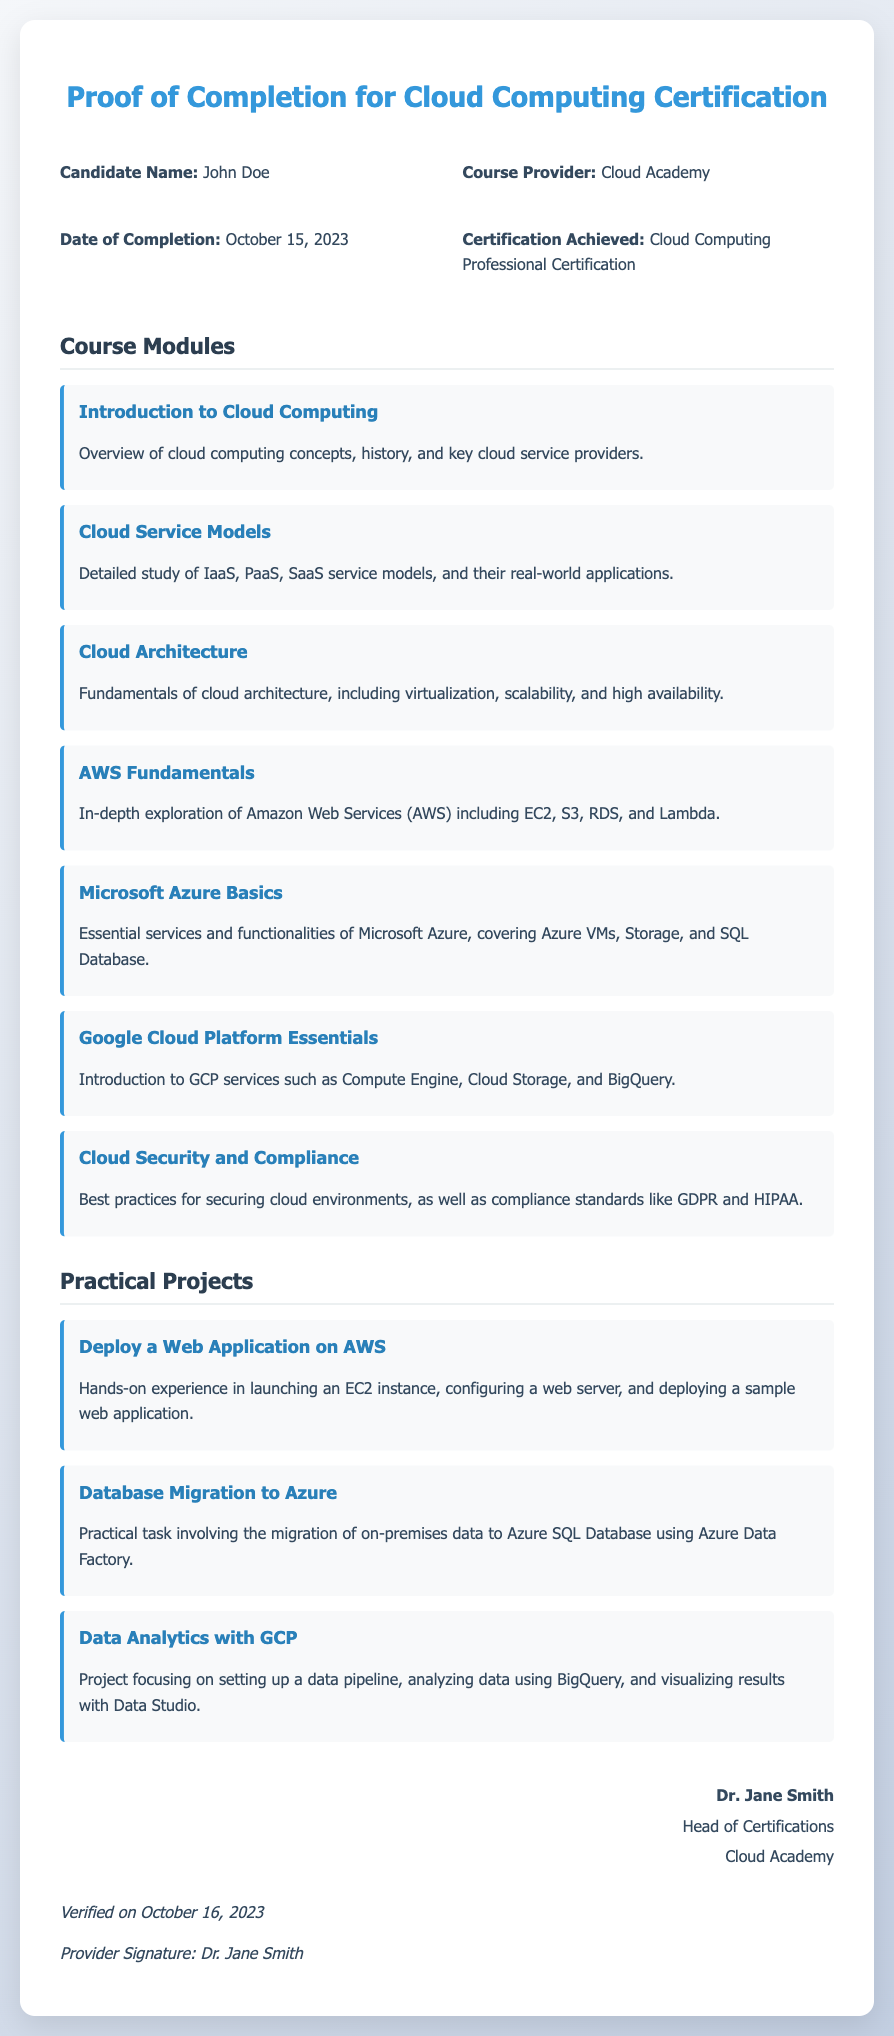what is the candidate's name? The candidate's name is explicitly stated in the document.
Answer: John Doe who is the course provider? The course provider is mentioned in the information section of the document.
Answer: Cloud Academy when did the candidate complete the course? The completion date can be found in the document's details.
Answer: October 15, 2023 what certification was achieved? The document specifies the certification that the candidate obtained.
Answer: Cloud Computing Professional Certification how many course modules are listed? By counting the modules mentioned in the section, we can find the total.
Answer: Seven which cloud platform is associated with the first practical project? The document describes the practical projects and the respective platforms used in each.
Answer: AWS who verified the affidavit? The document lists the individual who verified the completion of the certification.
Answer: Dr. Jane Smith what is the role of the verifier? The verifier's position is stated in the document.
Answer: Head of Certifications when was the document verified? The verification date is explicitly stated in the document.
Answer: October 16, 2023 